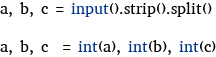<code> <loc_0><loc_0><loc_500><loc_500><_Python_>a, b, c = input().strip().split()

a, b, c  = int(a), int(b), int(c)</code> 